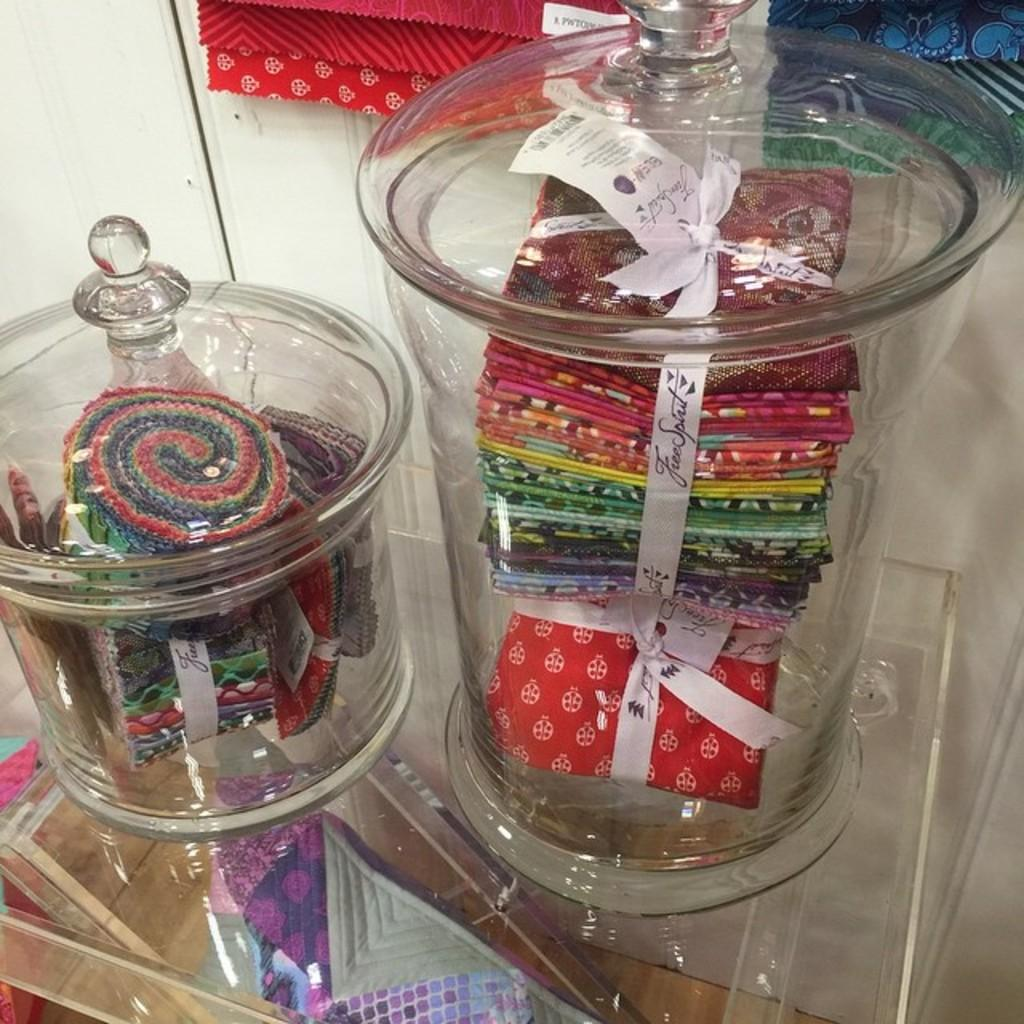What type of containers are visible in the image? The image contains jars made of glass. What are the jars holding? The jars contain clothes. What is the material of the desk in the image? The desk is made of glass. What can be seen in the background of the image? There is a wall in the background of the image. What is on the wall in the background? Clothes are present on the wall in the background. How does the payment process work for the clothes on the wall in the image? There is no information about payment in the image, as it only shows jars with clothes, a glass desk, and clothes on a wall. What is the digestion process of the clothes in the image? Clothes are not living organisms and do not have a digestion process; they are inanimate objects. 